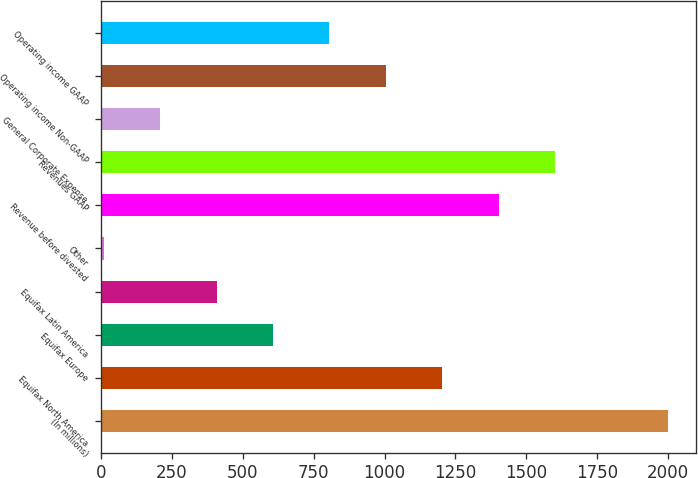<chart> <loc_0><loc_0><loc_500><loc_500><bar_chart><fcel>(In millions)<fcel>Equifax North America<fcel>Equifax Europe<fcel>Equifax Latin America<fcel>Other<fcel>Revenue before divested<fcel>Revenues GAAP<fcel>General Corporate Expense<fcel>Operating income Non-GAAP<fcel>Operating income GAAP<nl><fcel>2000<fcel>1203.84<fcel>606.72<fcel>407.68<fcel>9.6<fcel>1402.88<fcel>1601.92<fcel>208.64<fcel>1004.8<fcel>805.76<nl></chart> 